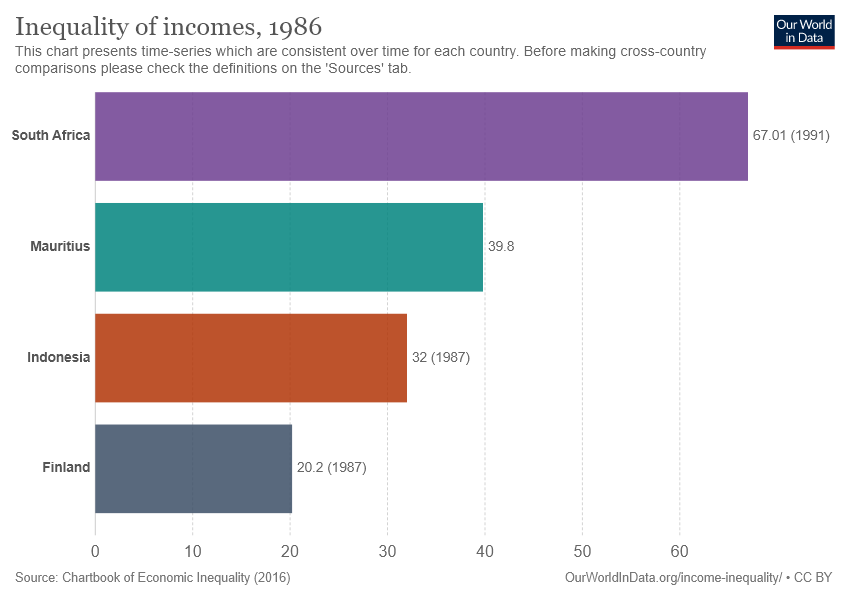Point out several critical features in this image. The average of all the countries together is 39.75. The red colored bar indicates that the data pertains to Indonesia. 